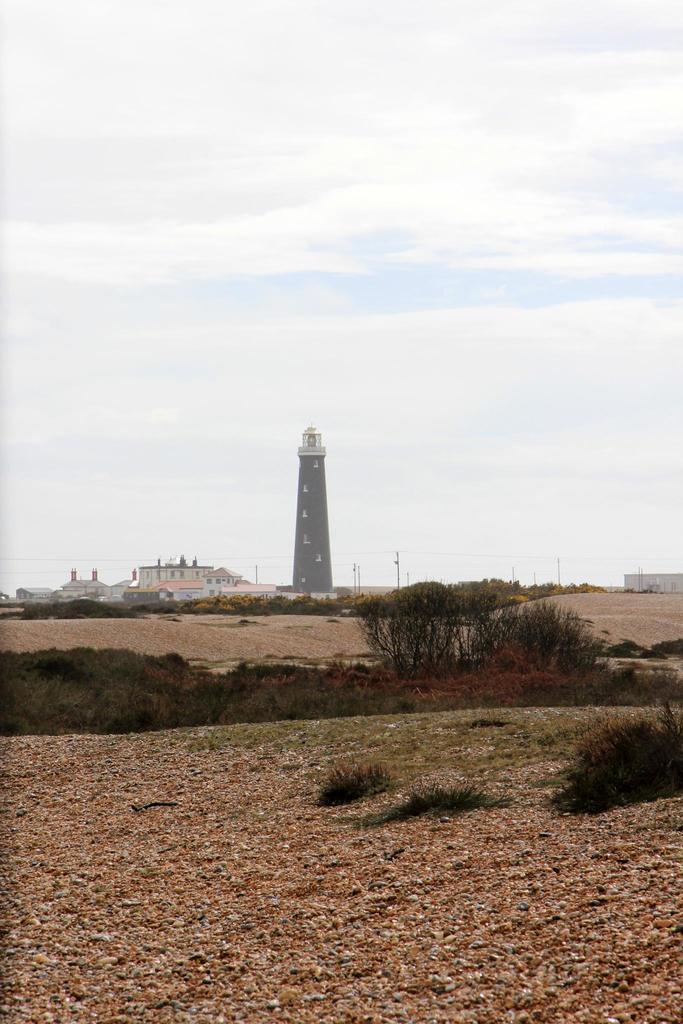Describe this image in one or two sentences. This picture might be taken from outside of the city. In this image, in the middle, we can see some trees and plants and a tower. On the right side, we can also see a house, electrical pole, electrical wires. On the left side, we can also see some buildings, windows, trees. On the top, we can see a sky, at the bottom there is a land. 